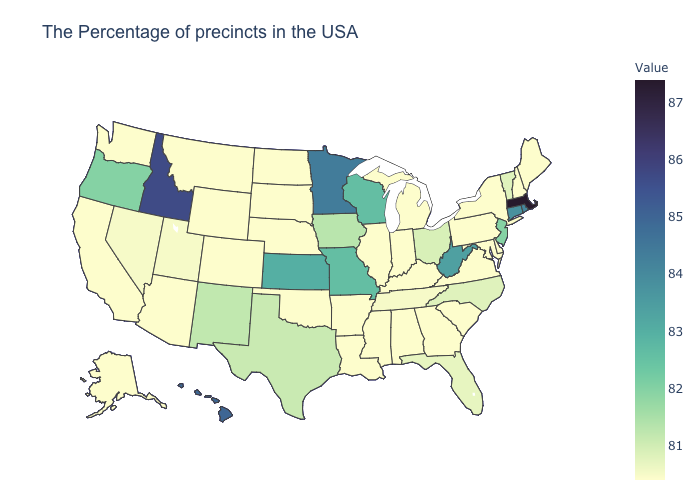Does Florida have the lowest value in the South?
Short answer required. No. Does North Carolina have the lowest value in the USA?
Give a very brief answer. No. Which states hav the highest value in the Northeast?
Concise answer only. Massachusetts. Among the states that border Arkansas , which have the lowest value?
Write a very short answer. Mississippi, Louisiana, Oklahoma. Which states have the lowest value in the USA?
Be succinct. Maine, New Hampshire, New York, Delaware, Maryland, Pennsylvania, Virginia, South Carolina, Georgia, Michigan, Kentucky, Indiana, Alabama, Illinois, Mississippi, Louisiana, Arkansas, Nebraska, Oklahoma, South Dakota, North Dakota, Wyoming, Colorado, Montana, Arizona, California, Washington, Alaska. Among the states that border Connecticut , which have the lowest value?
Concise answer only. New York. Does Idaho have the highest value in the West?
Write a very short answer. Yes. 